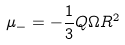<formula> <loc_0><loc_0><loc_500><loc_500>\mu _ { - } = - \frac { 1 } { 3 } Q \Omega R ^ { 2 }</formula> 